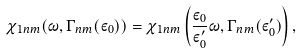Convert formula to latex. <formula><loc_0><loc_0><loc_500><loc_500>\chi _ { 1 n m } ( \omega , \Gamma _ { n m } ( \varepsilon _ { 0 } ) ) = \chi _ { 1 n m } \left ( \frac { \varepsilon _ { 0 } } { \varepsilon _ { 0 } ^ { \prime } } \omega , \Gamma _ { n m } ( \varepsilon _ { 0 } ^ { \prime } ) \right ) ,</formula> 